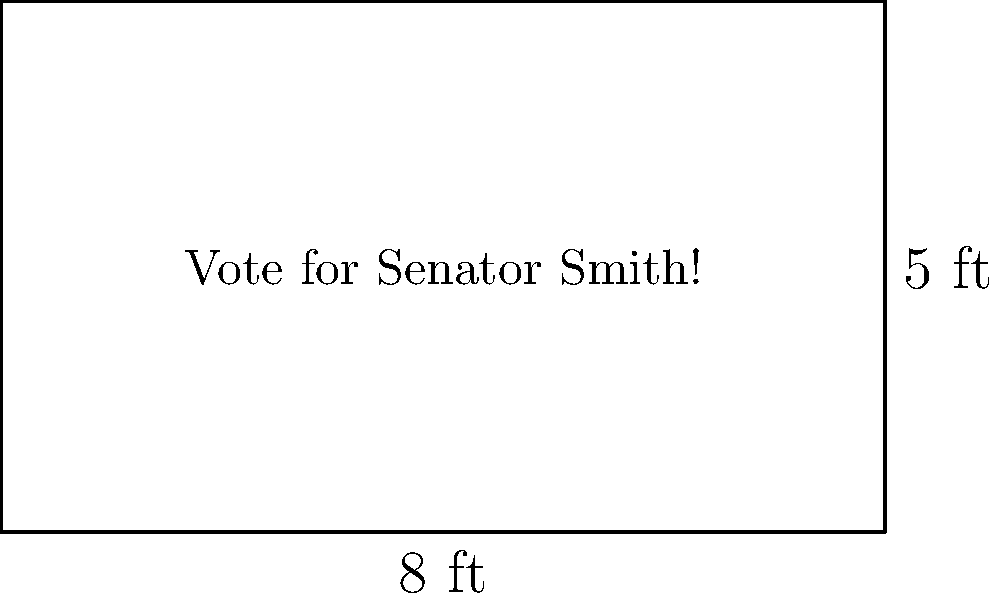As a dedicated supporter of Senator Smith, you're tasked with creating a rectangular campaign banner for an upcoming rally. The banner measures 8 feet in width and 5 feet in height. Calculate the total area of the banner in square feet to ensure you have enough space to prominently display the senator's key talking points and campaign slogan. To calculate the area of a rectangular banner, we need to multiply its width by its height. Let's break it down step-by-step:

1. Identify the given dimensions:
   - Width = 8 feet
   - Height = 5 feet

2. Apply the formula for the area of a rectangle:
   $$ \text{Area} = \text{Width} \times \text{Height} $$

3. Substitute the values into the formula:
   $$ \text{Area} = 8 \text{ feet} \times 5 \text{ feet} $$

4. Perform the multiplication:
   $$ \text{Area} = 40 \text{ square feet} $$

Therefore, the total area of the campaign banner is 40 square feet, providing ample space to showcase Senator Smith's conservative message and rally support for the upcoming election.
Answer: 40 square feet 